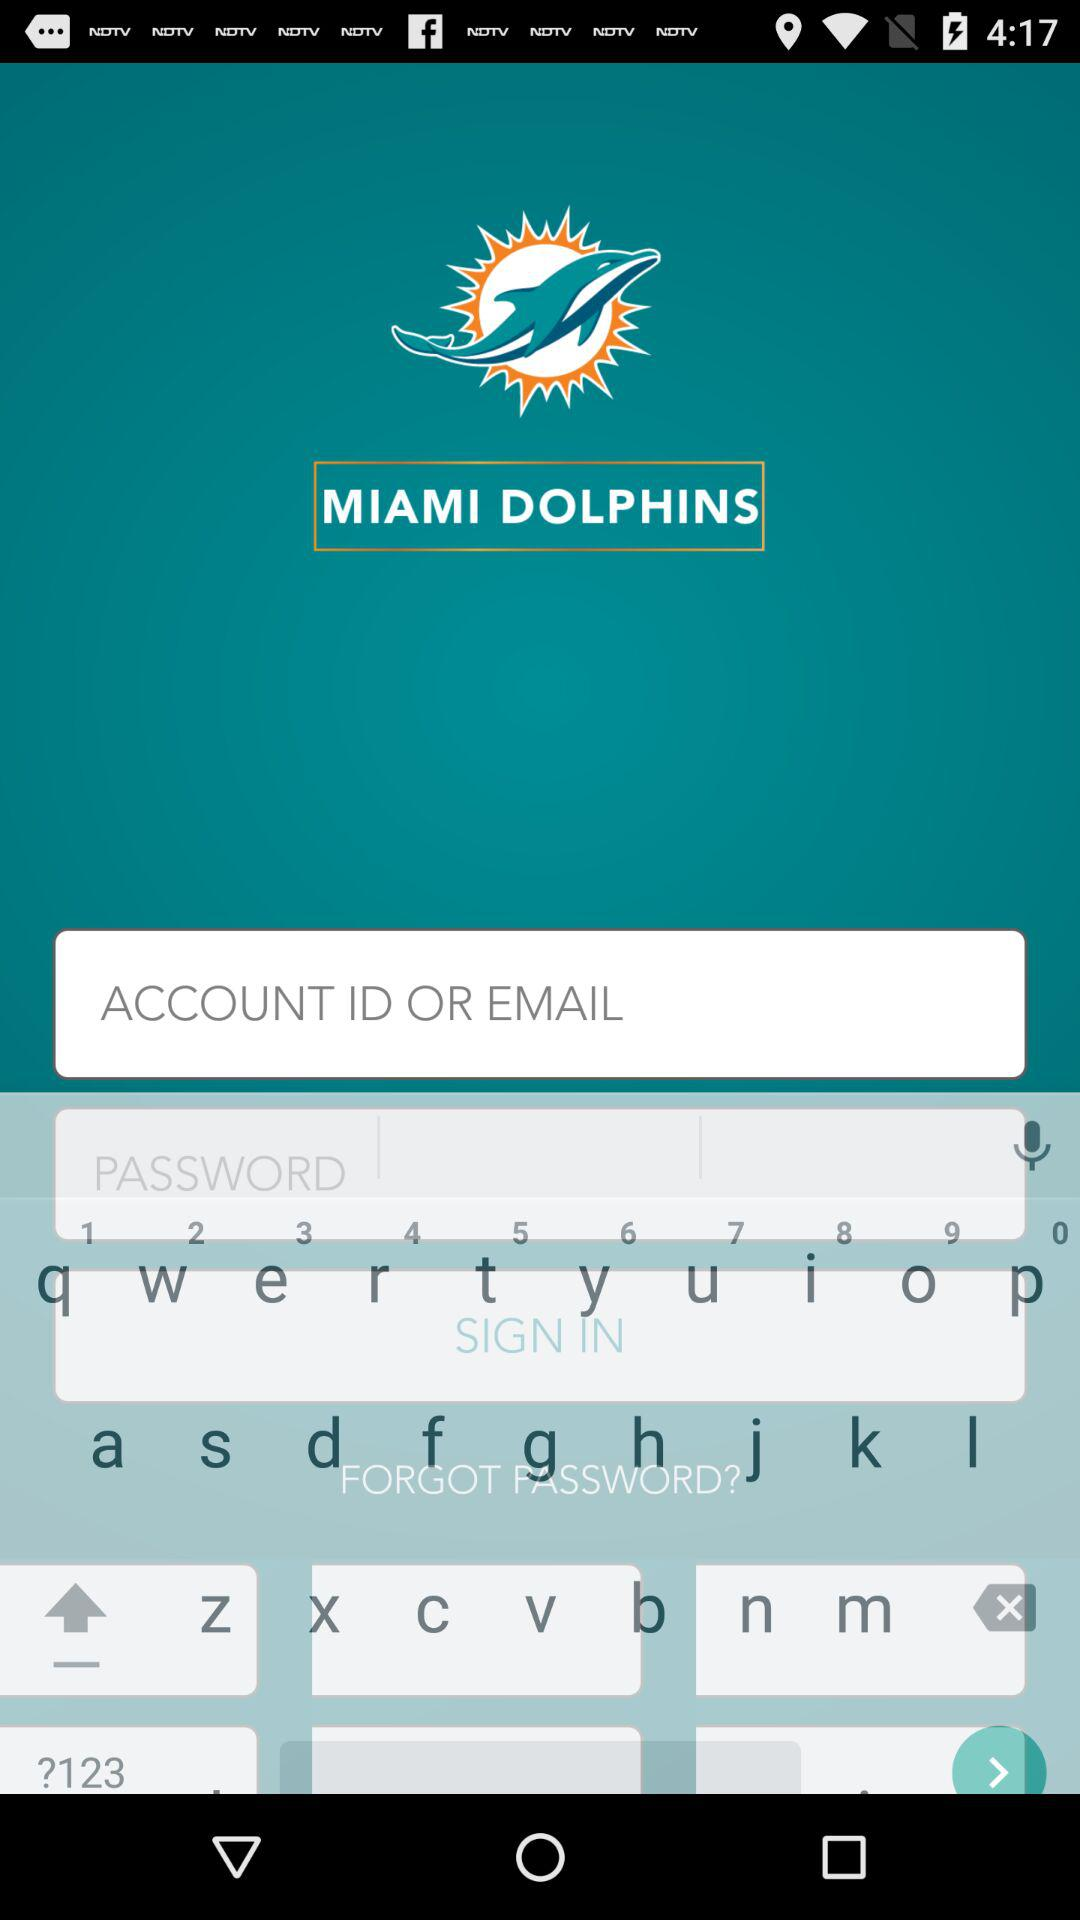What is the name of the application? The name of the application is "MIAMI DOLPHINS". 